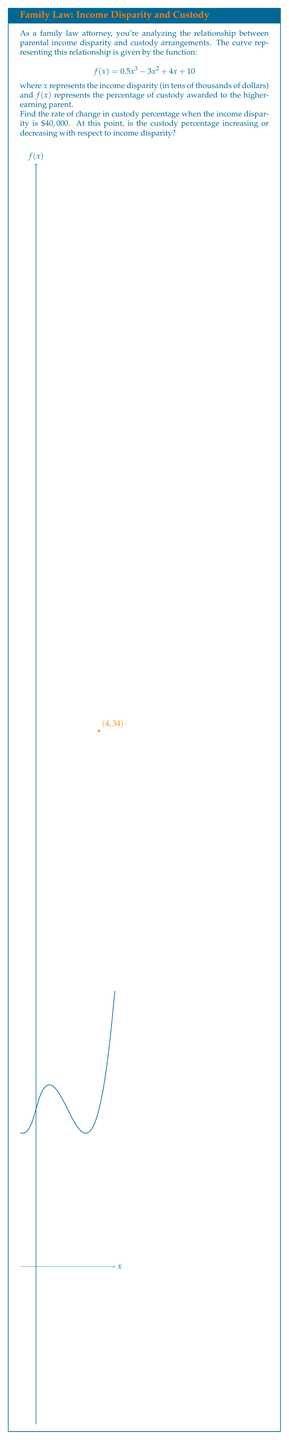Can you answer this question? To solve this problem, we need to follow these steps:

1) First, we need to find the derivative of the function $f(x)$. This will give us the rate of change at any point.

   $$f'(x) = \frac{d}{dx}(0.5x^3 - 3x^2 + 4x + 10)$$
   $$f'(x) = 1.5x^2 - 6x + 4$$

2) Now, we need to evaluate this derivative at $x = 4$ (since $40,000 = 4 * 10,000$).

   $$f'(4) = 1.5(4)^2 - 6(4) + 4$$
   $$f'(4) = 1.5(16) - 24 + 4$$
   $$f'(4) = 24 - 24 + 4 = 4$$

3) To determine if the custody percentage is increasing or decreasing, we look at the sign of the derivative:
   - If $f'(4) > 0$, the function is increasing at $x = 4$
   - If $f'(4) < 0$, the function is decreasing at $x = 4$

   Since $f'(4) = 4 > 0$, the function is increasing at $x = 4$.

Therefore, when the income disparity is $\$40,000$, the rate of change in custody percentage is 4% per $\$10,000$ of income disparity, and the custody percentage is increasing with respect to income disparity.
Answer: 4% per $10,000, increasing 